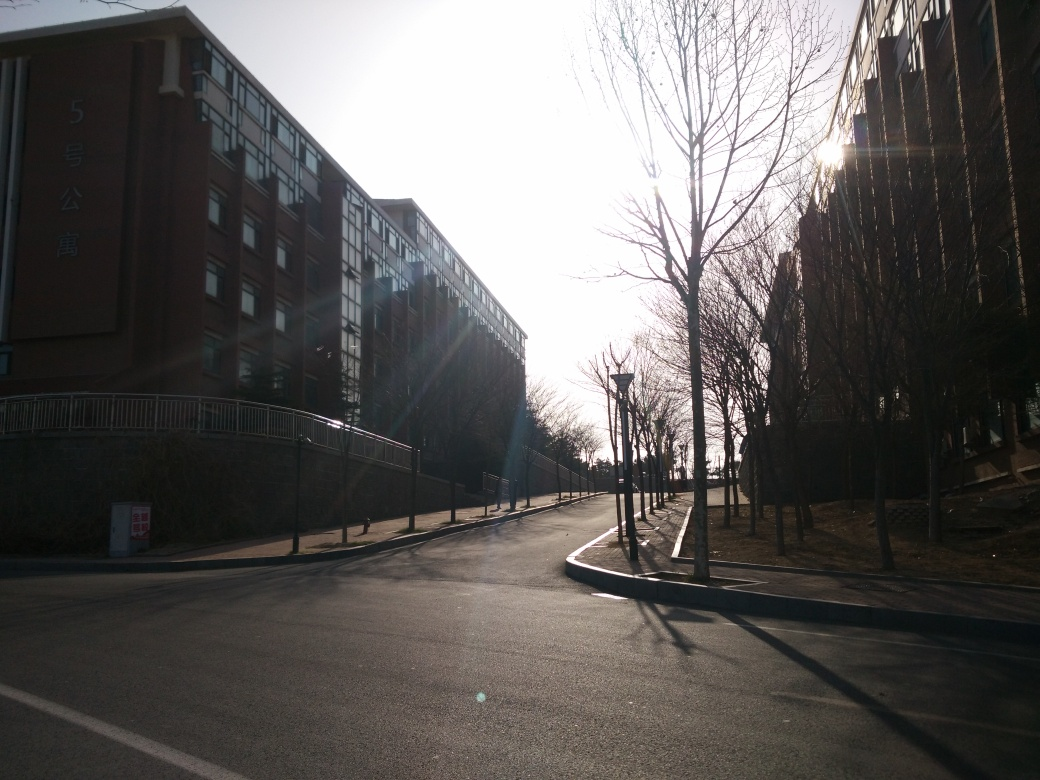Can you describe the setting of this photo? Certainly. The photo depicts an urban street scene during daytime with the sun low on the horizon, possibly morning or late afternoon. A row of bare trees lines the sidewalk, indicating it might be autumn or winter. A large building with a '5号楼' sign suggests a residential or institutional setting, perhaps apartments or a campus. The absence of people and the long shadows create a quiet, almost serene atmosphere. 